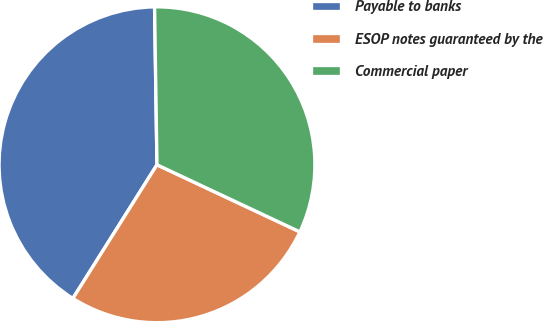Convert chart to OTSL. <chart><loc_0><loc_0><loc_500><loc_500><pie_chart><fcel>Payable to banks<fcel>ESOP notes guaranteed by the<fcel>Commercial paper<nl><fcel>40.82%<fcel>26.95%<fcel>32.23%<nl></chart> 